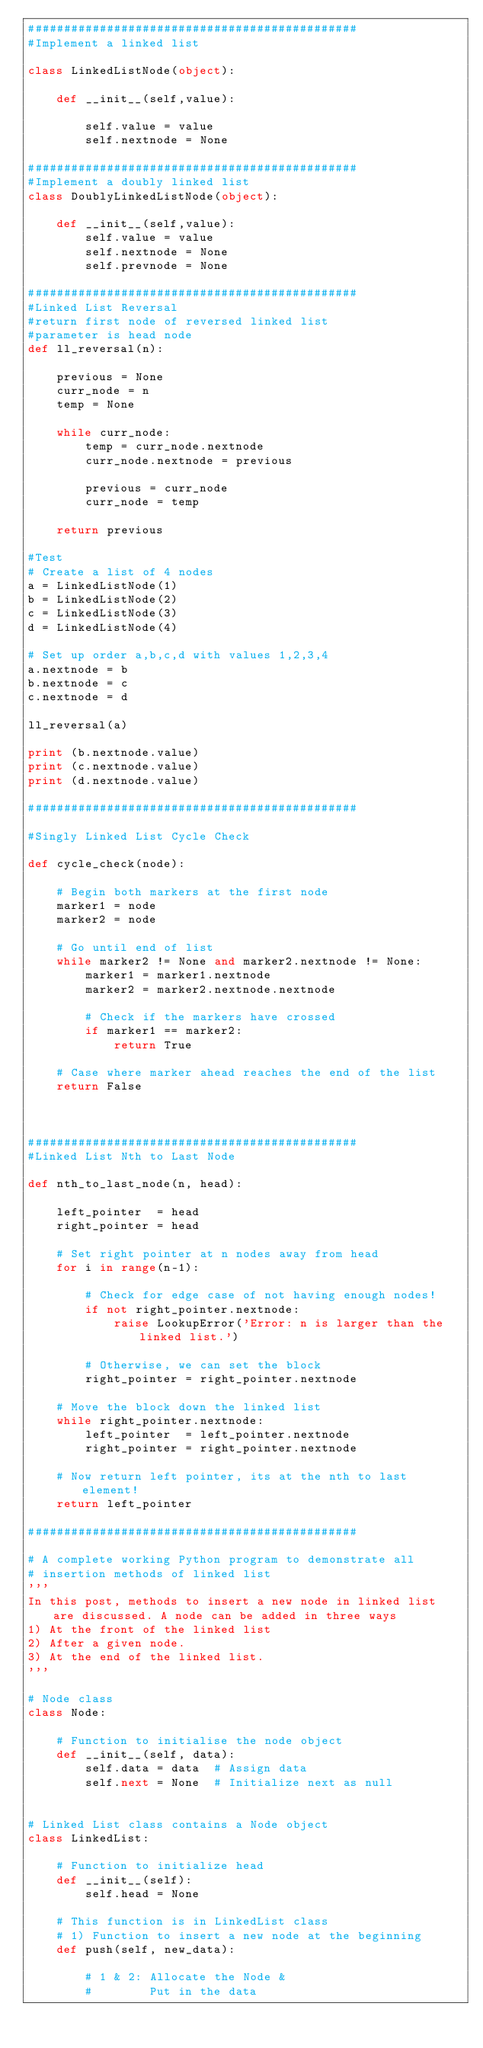Convert code to text. <code><loc_0><loc_0><loc_500><loc_500><_Python_>##############################################
#Implement a linked list

class LinkedListNode(object):
    
    def __init__(self,value):
        
        self.value = value
        self.nextnode = None
 
##############################################
#Implement a doubly linked list
class DoublyLinkedListNode(object):
    
    def __init__(self,value):
        self.value = value
        self.nextnode = None
        self.prevnode = None

##############################################
#Linked List Reversal
#return first node of reversed linked list
#parameter is head node
def ll_reversal(n):
    
    previous = None
    curr_node = n
    temp = None
    
    while curr_node:
        temp = curr_node.nextnode
        curr_node.nextnode = previous
        
        previous = curr_node
        curr_node = temp
        
    return previous

#Test
# Create a list of 4 nodes
a = LinkedListNode(1)
b = LinkedListNode(2)
c = LinkedListNode(3)
d = LinkedListNode(4)

# Set up order a,b,c,d with values 1,2,3,4
a.nextnode = b
b.nextnode = c
c.nextnode = d

ll_reversal(a)

print (b.nextnode.value)
print (c.nextnode.value)
print (d.nextnode.value)
 
##############################################

#Singly Linked List Cycle Check

def cycle_check(node):
    
    # Begin both markers at the first node
    marker1 = node
    marker2 = node
    
    # Go until end of list
    while marker2 != None and marker2.nextnode != None:
        marker1 = marker1.nextnode
        marker2 = marker2.nextnode.nextnode
        
        # Check if the markers have crossed
        if marker1 == marker2:
            return True
        
    # Case where marker ahead reaches the end of the list
    return False
        

 
##############################################
#Linked List Nth to Last Node

def nth_to_last_node(n, head):

    left_pointer  = head
    right_pointer = head

    # Set right pointer at n nodes away from head
    for i in range(n-1):
        
        # Check for edge case of not having enough nodes!
        if not right_pointer.nextnode:
            raise LookupError('Error: n is larger than the linked list.')

        # Otherwise, we can set the block
        right_pointer = right_pointer.nextnode

    # Move the block down the linked list
    while right_pointer.nextnode:
        left_pointer  = left_pointer.nextnode
        right_pointer = right_pointer.nextnode

    # Now return left pointer, its at the nth to last element!
    return left_pointer
 
##############################################

# A complete working Python program to demonstrate all
# insertion methods of linked list
'''
In this post, methods to insert a new node in linked list are discussed. A node can be added in three ways
1) At the front of the linked list
2) After a given node.
3) At the end of the linked list.
'''

# Node class
class Node:
 
    # Function to initialise the node object
    def __init__(self, data):
        self.data = data  # Assign data
        self.next = None  # Initialize next as null
 
 
# Linked List class contains a Node object
class LinkedList:
 
    # Function to initialize head
    def __init__(self):
        self.head = None
        
    # This function is in LinkedList class
    # 1) Function to insert a new node at the beginning
    def push(self, new_data):

        # 1 & 2: Allocate the Node &
        #        Put in the data</code> 